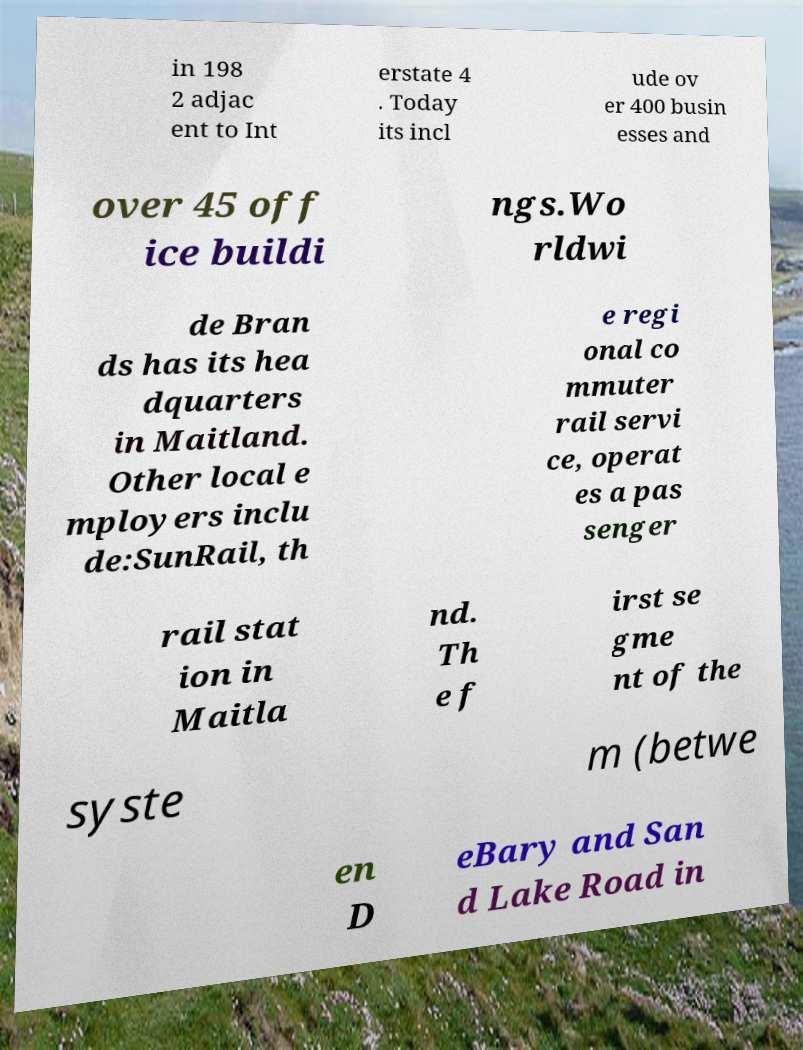I need the written content from this picture converted into text. Can you do that? in 198 2 adjac ent to Int erstate 4 . Today its incl ude ov er 400 busin esses and over 45 off ice buildi ngs.Wo rldwi de Bran ds has its hea dquarters in Maitland. Other local e mployers inclu de:SunRail, th e regi onal co mmuter rail servi ce, operat es a pas senger rail stat ion in Maitla nd. Th e f irst se gme nt of the syste m (betwe en D eBary and San d Lake Road in 